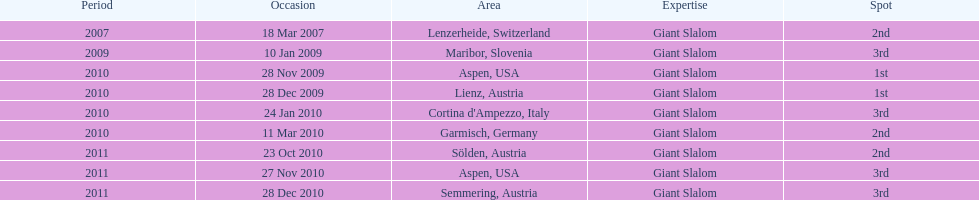What is the only location in the us? Aspen. 